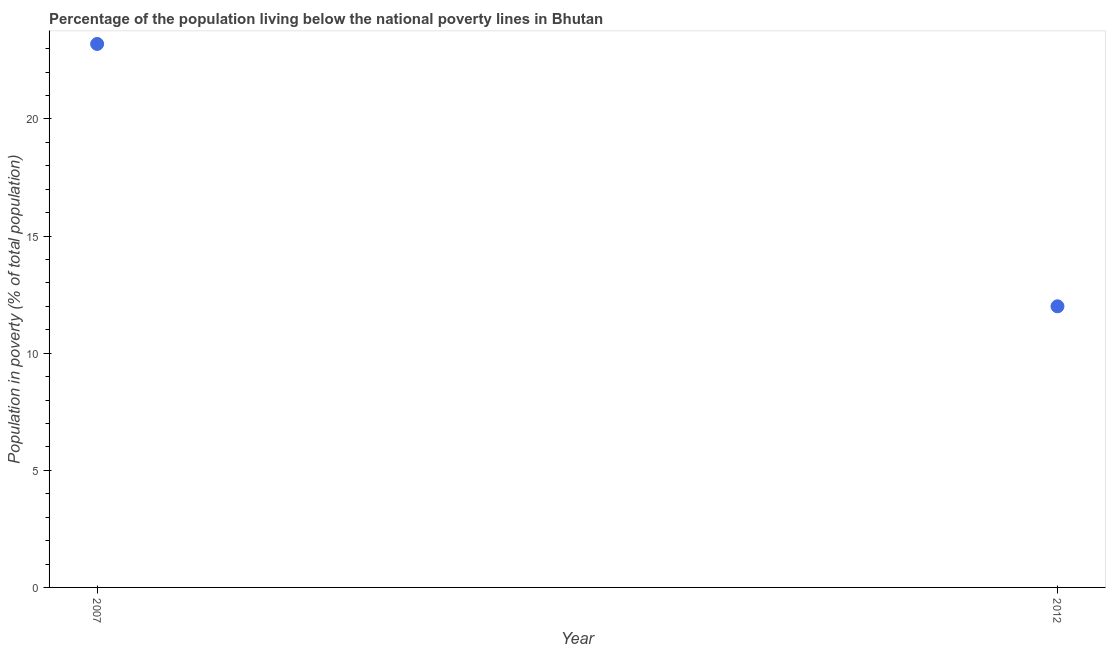What is the percentage of population living below poverty line in 2007?
Ensure brevity in your answer.  23.2. Across all years, what is the maximum percentage of population living below poverty line?
Your response must be concise. 23.2. What is the sum of the percentage of population living below poverty line?
Offer a very short reply. 35.2. In how many years, is the percentage of population living below poverty line greater than 4 %?
Your answer should be very brief. 2. Do a majority of the years between 2007 and 2012 (inclusive) have percentage of population living below poverty line greater than 2 %?
Provide a succinct answer. Yes. What is the ratio of the percentage of population living below poverty line in 2007 to that in 2012?
Your answer should be compact. 1.93. Is the percentage of population living below poverty line in 2007 less than that in 2012?
Make the answer very short. No. Does the percentage of population living below poverty line monotonically increase over the years?
Provide a short and direct response. No. How many years are there in the graph?
Make the answer very short. 2. Are the values on the major ticks of Y-axis written in scientific E-notation?
Provide a short and direct response. No. What is the title of the graph?
Provide a succinct answer. Percentage of the population living below the national poverty lines in Bhutan. What is the label or title of the Y-axis?
Your answer should be very brief. Population in poverty (% of total population). What is the Population in poverty (% of total population) in 2007?
Give a very brief answer. 23.2. What is the ratio of the Population in poverty (% of total population) in 2007 to that in 2012?
Your response must be concise. 1.93. 